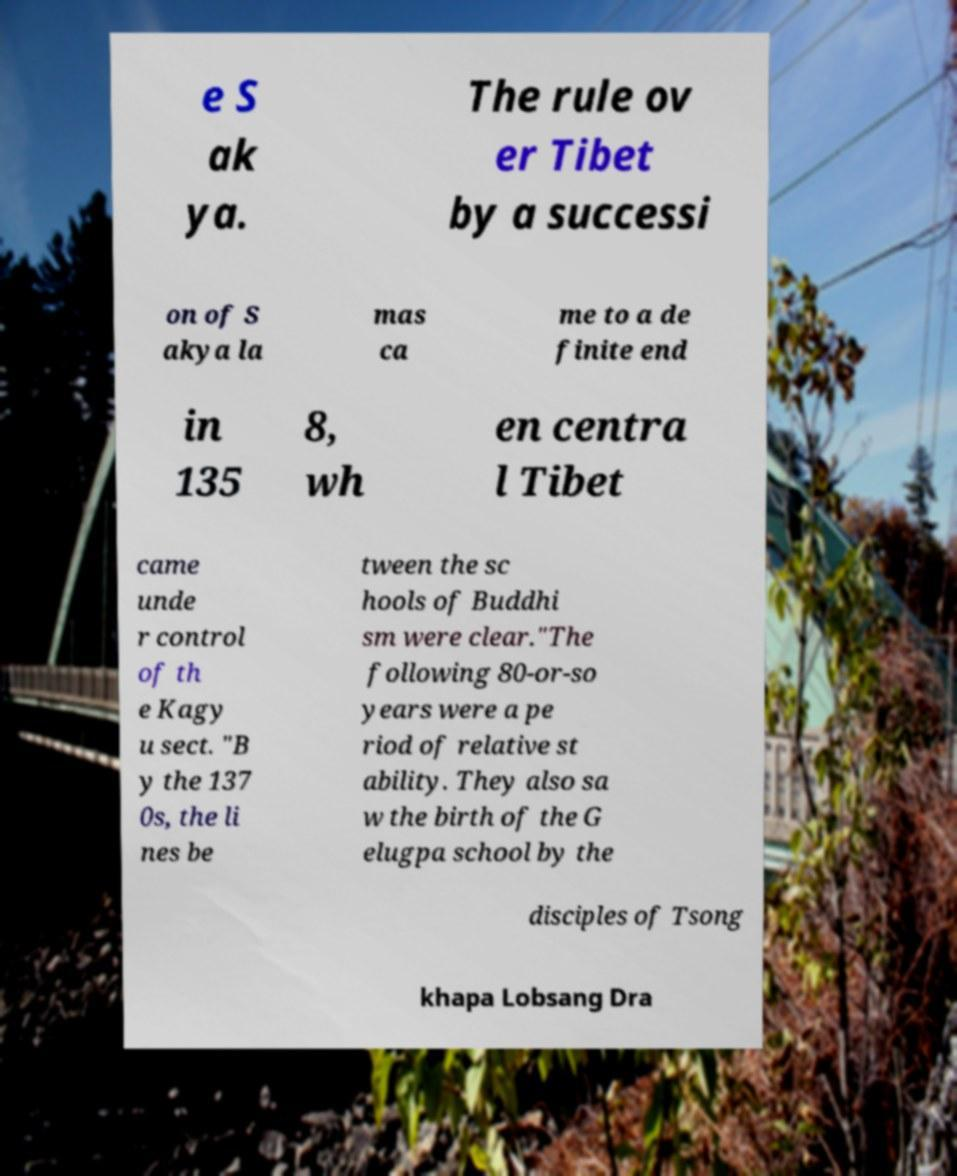What messages or text are displayed in this image? I need them in a readable, typed format. e S ak ya. The rule ov er Tibet by a successi on of S akya la mas ca me to a de finite end in 135 8, wh en centra l Tibet came unde r control of th e Kagy u sect. "B y the 137 0s, the li nes be tween the sc hools of Buddhi sm were clear."The following 80-or-so years were a pe riod of relative st ability. They also sa w the birth of the G elugpa school by the disciples of Tsong khapa Lobsang Dra 